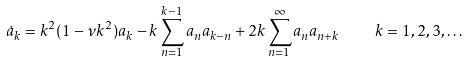<formula> <loc_0><loc_0><loc_500><loc_500>\dot { a } _ { k } = k ^ { 2 } ( 1 - \nu k ^ { 2 } ) a _ { k } - k \sum _ { n = 1 } ^ { k - 1 } a _ { n } a _ { k - n } + 2 k \sum _ { n = 1 } ^ { \infty } a _ { n } a _ { n + k } \quad k = 1 , 2 , 3 , \dots</formula> 